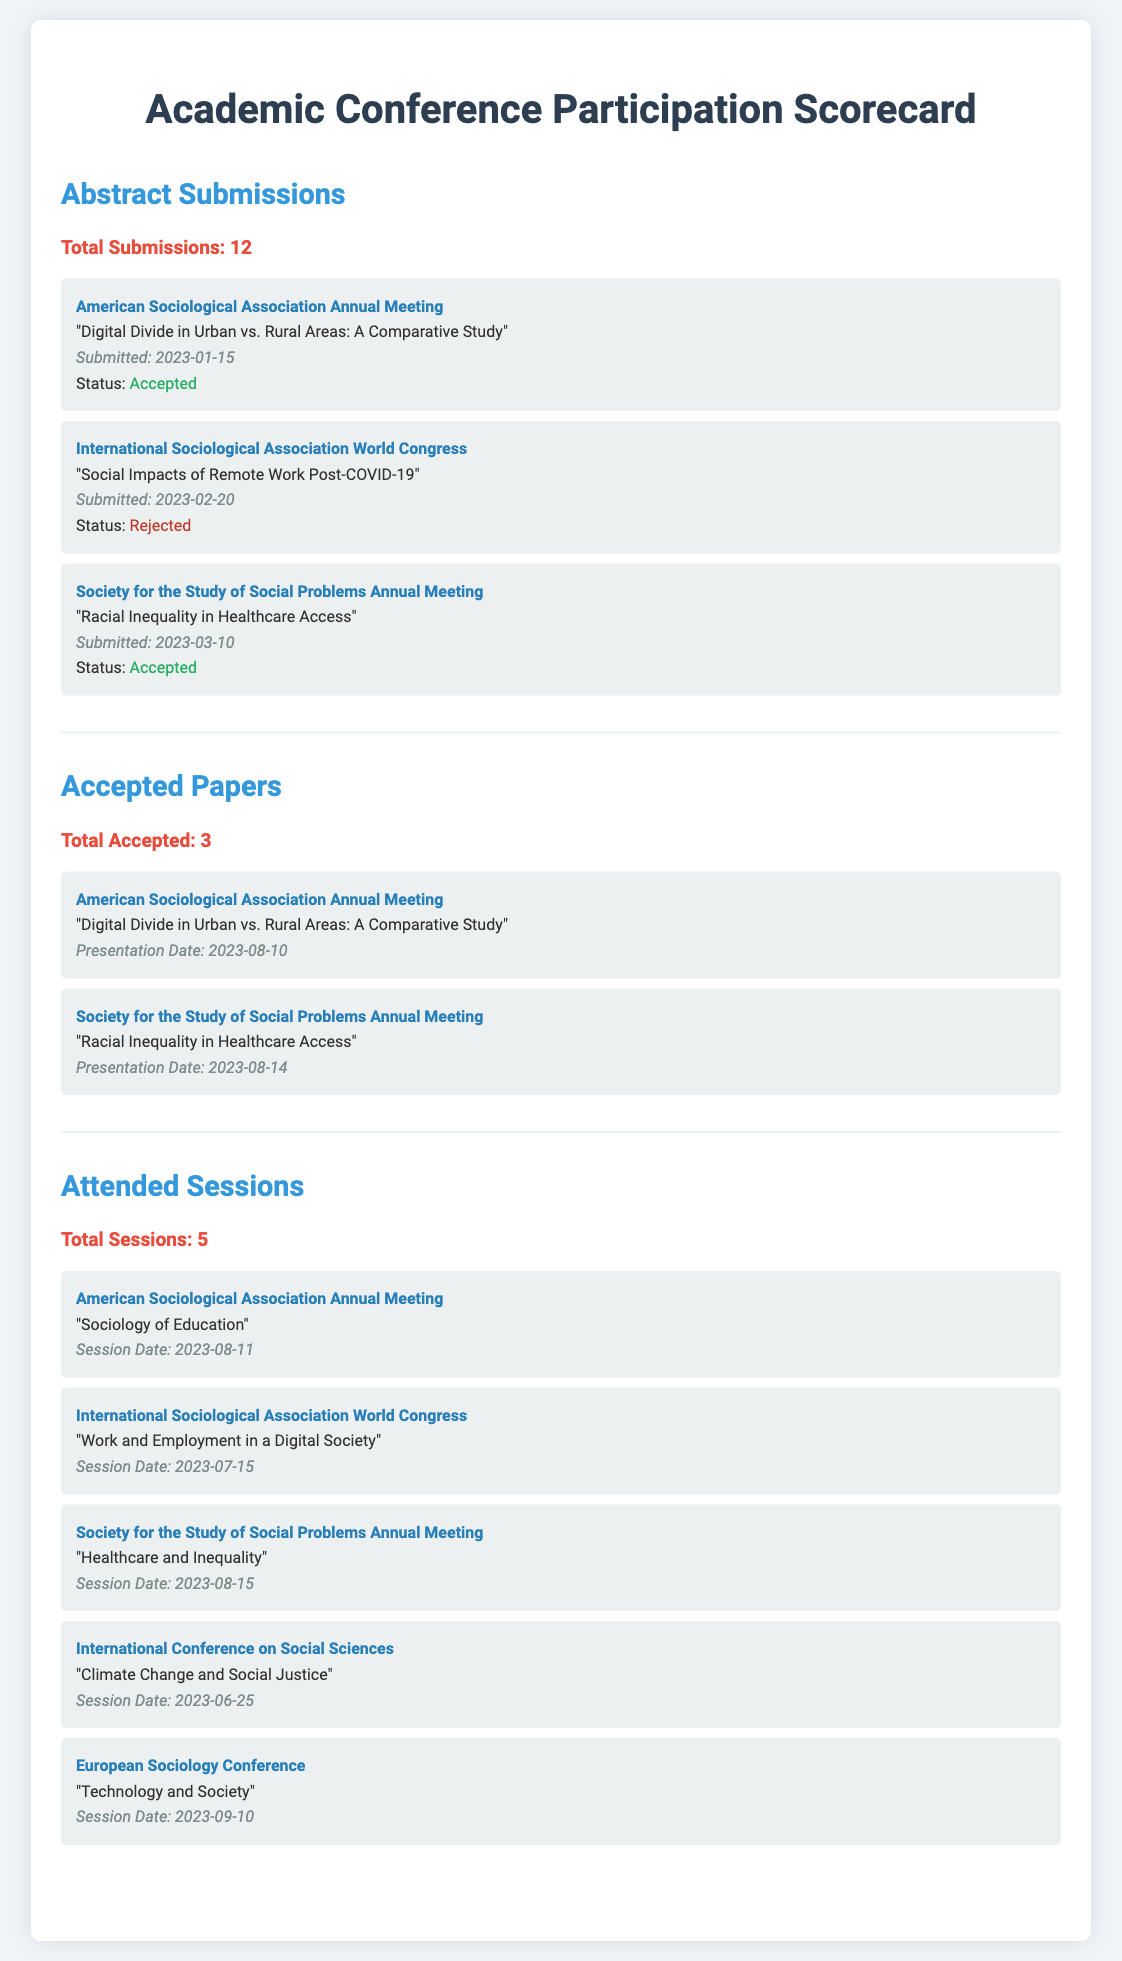what is the total number of abstract submissions? The document states that the total number of abstract submissions is 12.
Answer: 12 how many accepted papers were presented? The document lists 3 accepted papers, indicating the number of presentations.
Answer: 3 which conference had an abstract rejected? The document specifies that the International Sociological Association World Congress had an abstract rejected.
Answer: International Sociological Association World Congress what was the title of the accepted paper presented at the American Sociological Association Annual Meeting? The title of the accepted paper presented at the American Sociological Association Annual Meeting is "Digital Divide in Urban vs. Rural Areas: A Comparative Study."
Answer: Digital Divide in Urban vs. Rural Areas: A Comparative Study how many sessions were attended in total? The document indicates that a total of 5 sessions were attended by the participant.
Answer: 5 which session was attended on the date 2023-08-11? The document lists that the session "Sociology of Education" was attended on the date 2023-08-11.
Answer: Sociology of Education what is the date of the presentation for the accepted paper on "Racial Inequality in Healthcare Access"? The presentation for the accepted paper on "Racial Inequality in Healthcare Access" occurred on 2023-08-14.
Answer: 2023-08-14 how many total sessions were attended at the International Sociological Association World Congress? The document shows that 1 session was attended at the International Sociological Association World Congress.
Answer: 1 which conference focused on "Technology and Society"? The document states that the European Sociology Conference focused on "Technology and Society."
Answer: European Sociology Conference 